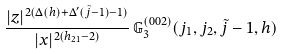Convert formula to latex. <formula><loc_0><loc_0><loc_500><loc_500>\frac { | z | ^ { 2 ( \Delta ( h ) + \Delta ^ { \prime } ( \tilde { j } - 1 ) - 1 ) } } { | x | ^ { 2 ( h _ { 2 1 } - 2 ) } } \, { \mathbb { G } } ^ { ( 0 0 2 ) } _ { 3 } ( j _ { 1 } , j _ { 2 } , \tilde { j } - 1 , h )</formula> 